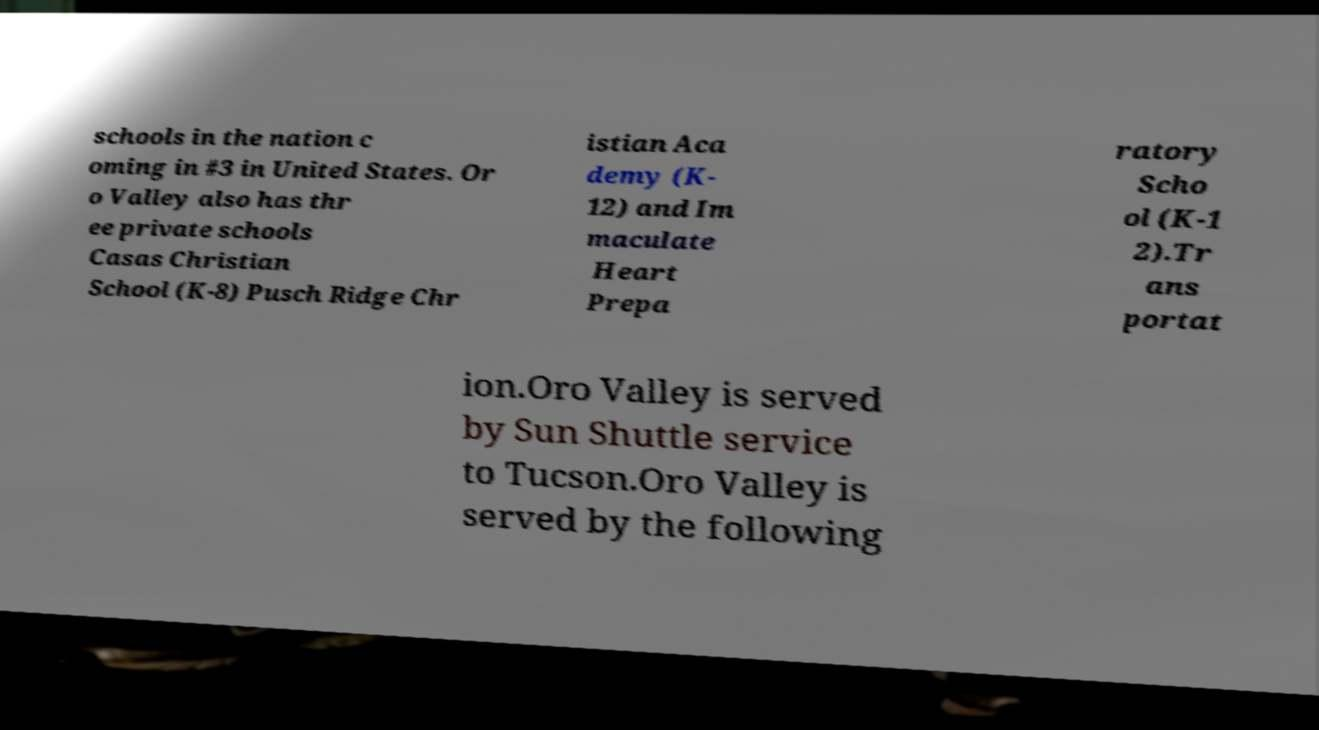There's text embedded in this image that I need extracted. Can you transcribe it verbatim? schools in the nation c oming in #3 in United States. Or o Valley also has thr ee private schools Casas Christian School (K-8) Pusch Ridge Chr istian Aca demy (K- 12) and Im maculate Heart Prepa ratory Scho ol (K-1 2).Tr ans portat ion.Oro Valley is served by Sun Shuttle service to Tucson.Oro Valley is served by the following 